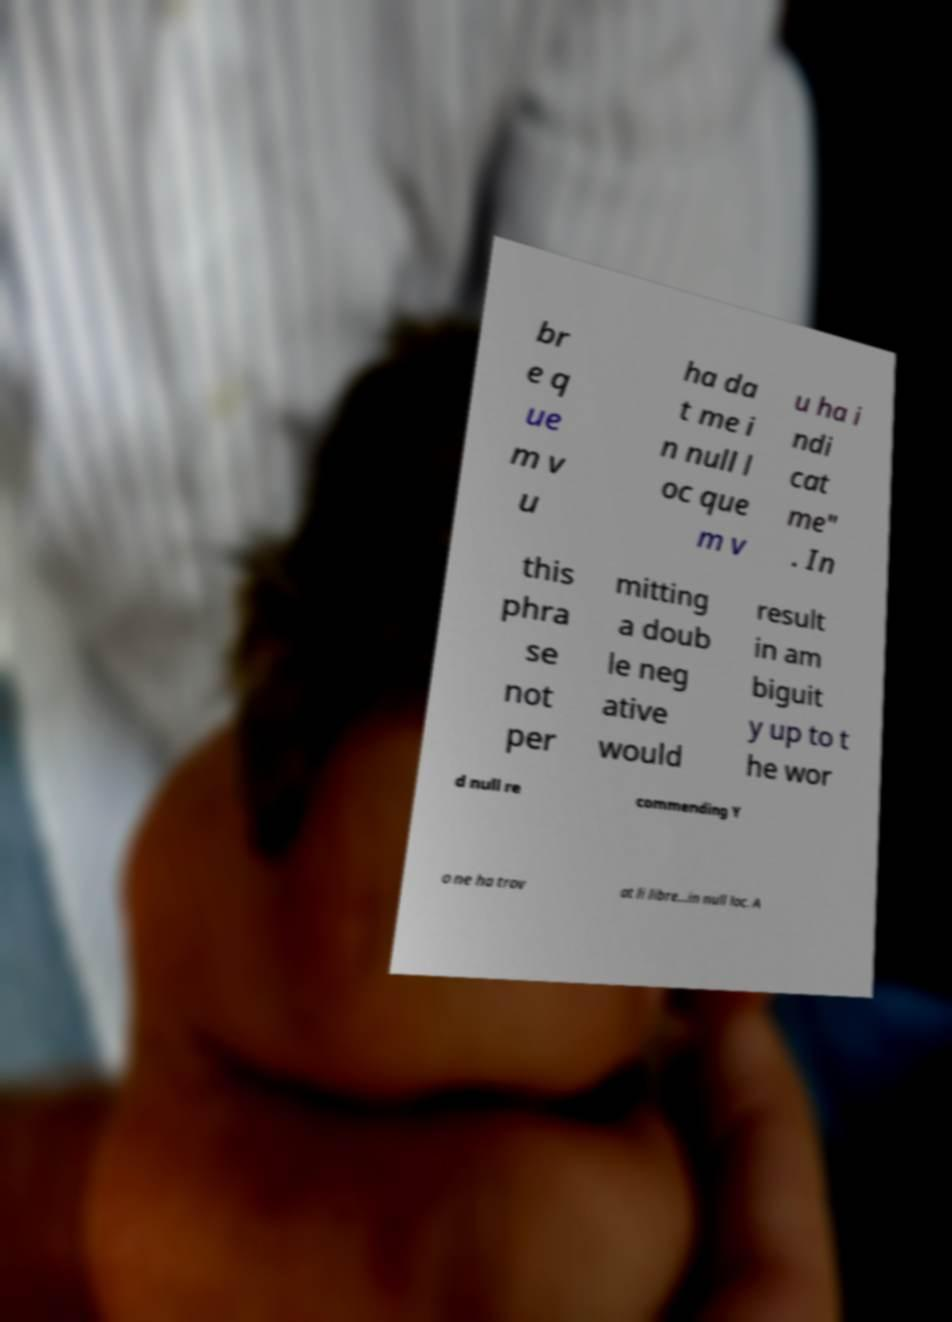What messages or text are displayed in this image? I need them in a readable, typed format. br e q ue m v u ha da t me i n null l oc que m v u ha i ndi cat me" . In this phra se not per mitting a doub le neg ative would result in am biguit y up to t he wor d null re commending Y o ne ha trov at li libre...in null loc. A 